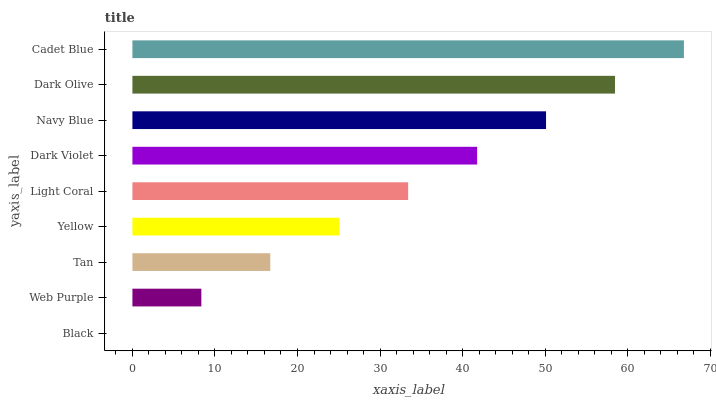Is Black the minimum?
Answer yes or no. Yes. Is Cadet Blue the maximum?
Answer yes or no. Yes. Is Web Purple the minimum?
Answer yes or no. No. Is Web Purple the maximum?
Answer yes or no. No. Is Web Purple greater than Black?
Answer yes or no. Yes. Is Black less than Web Purple?
Answer yes or no. Yes. Is Black greater than Web Purple?
Answer yes or no. No. Is Web Purple less than Black?
Answer yes or no. No. Is Light Coral the high median?
Answer yes or no. Yes. Is Light Coral the low median?
Answer yes or no. Yes. Is Cadet Blue the high median?
Answer yes or no. No. Is Dark Violet the low median?
Answer yes or no. No. 